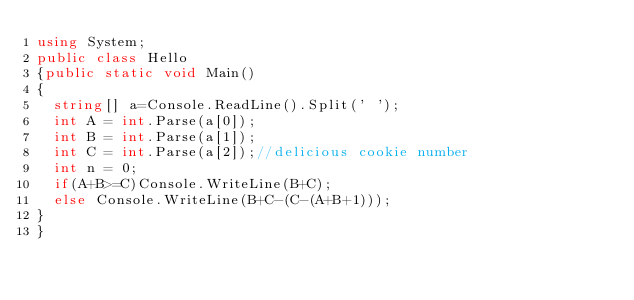<code> <loc_0><loc_0><loc_500><loc_500><_C#_>using System;
public class Hello
{public static void Main()
{
  string[] a=Console.ReadLine().Split(' ');
  int A = int.Parse(a[0]);
  int B = int.Parse(a[1]);
  int C = int.Parse(a[2]);//delicious cookie number
  int n = 0;
  if(A+B>=C)Console.WriteLine(B+C);
  else Console.WriteLine(B+C-(C-(A+B+1)));
}
}</code> 